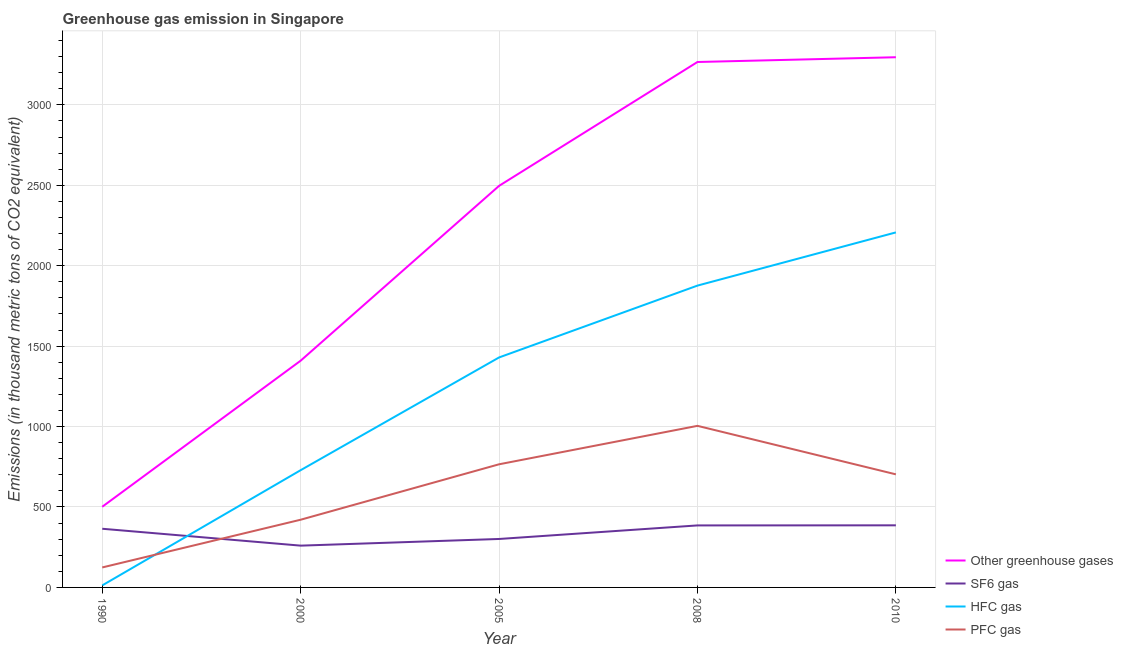How many different coloured lines are there?
Provide a short and direct response. 4. Does the line corresponding to emission of hfc gas intersect with the line corresponding to emission of pfc gas?
Your answer should be very brief. Yes. What is the emission of hfc gas in 2005?
Your answer should be compact. 1429.7. Across all years, what is the maximum emission of greenhouse gases?
Provide a succinct answer. 3296. Across all years, what is the minimum emission of pfc gas?
Offer a terse response. 124.2. In which year was the emission of sf6 gas minimum?
Provide a succinct answer. 2000. What is the total emission of greenhouse gases in the graph?
Your answer should be very brief. 1.10e+04. What is the difference between the emission of hfc gas in 2000 and that in 2005?
Your response must be concise. -700.8. What is the difference between the emission of hfc gas in 2008 and the emission of greenhouse gases in 2010?
Make the answer very short. -1419.6. What is the average emission of pfc gas per year?
Your answer should be very brief. 603.62. In the year 1990, what is the difference between the emission of greenhouse gases and emission of sf6 gas?
Your response must be concise. 136.8. What is the ratio of the emission of sf6 gas in 1990 to that in 2000?
Provide a succinct answer. 1.4. Is the emission of greenhouse gases in 1990 less than that in 2000?
Your answer should be very brief. Yes. Is the difference between the emission of sf6 gas in 2000 and 2008 greater than the difference between the emission of hfc gas in 2000 and 2008?
Provide a succinct answer. Yes. What is the difference between the highest and the lowest emission of hfc gas?
Make the answer very short. 2194.4. In how many years, is the emission of pfc gas greater than the average emission of pfc gas taken over all years?
Offer a very short reply. 3. Is it the case that in every year, the sum of the emission of greenhouse gases and emission of hfc gas is greater than the sum of emission of sf6 gas and emission of pfc gas?
Ensure brevity in your answer.  No. Is it the case that in every year, the sum of the emission of greenhouse gases and emission of sf6 gas is greater than the emission of hfc gas?
Make the answer very short. Yes. Does the emission of hfc gas monotonically increase over the years?
Ensure brevity in your answer.  Yes. Does the graph contain any zero values?
Provide a succinct answer. No. Does the graph contain grids?
Keep it short and to the point. Yes. Where does the legend appear in the graph?
Your response must be concise. Bottom right. How many legend labels are there?
Keep it short and to the point. 4. How are the legend labels stacked?
Give a very brief answer. Vertical. What is the title of the graph?
Your answer should be compact. Greenhouse gas emission in Singapore. Does "Argument" appear as one of the legend labels in the graph?
Keep it short and to the point. No. What is the label or title of the X-axis?
Your response must be concise. Year. What is the label or title of the Y-axis?
Provide a succinct answer. Emissions (in thousand metric tons of CO2 equivalent). What is the Emissions (in thousand metric tons of CO2 equivalent) in Other greenhouse gases in 1990?
Provide a short and direct response. 501.5. What is the Emissions (in thousand metric tons of CO2 equivalent) of SF6 gas in 1990?
Your response must be concise. 364.7. What is the Emissions (in thousand metric tons of CO2 equivalent) in HFC gas in 1990?
Your response must be concise. 12.6. What is the Emissions (in thousand metric tons of CO2 equivalent) of PFC gas in 1990?
Offer a terse response. 124.2. What is the Emissions (in thousand metric tons of CO2 equivalent) of Other greenhouse gases in 2000?
Your answer should be very brief. 1409.6. What is the Emissions (in thousand metric tons of CO2 equivalent) in SF6 gas in 2000?
Give a very brief answer. 259.8. What is the Emissions (in thousand metric tons of CO2 equivalent) in HFC gas in 2000?
Provide a succinct answer. 728.9. What is the Emissions (in thousand metric tons of CO2 equivalent) in PFC gas in 2000?
Your answer should be very brief. 420.9. What is the Emissions (in thousand metric tons of CO2 equivalent) in Other greenhouse gases in 2005?
Provide a short and direct response. 2496.4. What is the Emissions (in thousand metric tons of CO2 equivalent) of SF6 gas in 2005?
Provide a succinct answer. 301.2. What is the Emissions (in thousand metric tons of CO2 equivalent) in HFC gas in 2005?
Keep it short and to the point. 1429.7. What is the Emissions (in thousand metric tons of CO2 equivalent) in PFC gas in 2005?
Your response must be concise. 765.5. What is the Emissions (in thousand metric tons of CO2 equivalent) of Other greenhouse gases in 2008?
Provide a succinct answer. 3266.4. What is the Emissions (in thousand metric tons of CO2 equivalent) of SF6 gas in 2008?
Your response must be concise. 385.5. What is the Emissions (in thousand metric tons of CO2 equivalent) of HFC gas in 2008?
Make the answer very short. 1876.4. What is the Emissions (in thousand metric tons of CO2 equivalent) of PFC gas in 2008?
Ensure brevity in your answer.  1004.5. What is the Emissions (in thousand metric tons of CO2 equivalent) in Other greenhouse gases in 2010?
Offer a terse response. 3296. What is the Emissions (in thousand metric tons of CO2 equivalent) of SF6 gas in 2010?
Keep it short and to the point. 386. What is the Emissions (in thousand metric tons of CO2 equivalent) of HFC gas in 2010?
Make the answer very short. 2207. What is the Emissions (in thousand metric tons of CO2 equivalent) in PFC gas in 2010?
Make the answer very short. 703. Across all years, what is the maximum Emissions (in thousand metric tons of CO2 equivalent) of Other greenhouse gases?
Your answer should be very brief. 3296. Across all years, what is the maximum Emissions (in thousand metric tons of CO2 equivalent) in SF6 gas?
Your response must be concise. 386. Across all years, what is the maximum Emissions (in thousand metric tons of CO2 equivalent) of HFC gas?
Offer a very short reply. 2207. Across all years, what is the maximum Emissions (in thousand metric tons of CO2 equivalent) in PFC gas?
Make the answer very short. 1004.5. Across all years, what is the minimum Emissions (in thousand metric tons of CO2 equivalent) in Other greenhouse gases?
Make the answer very short. 501.5. Across all years, what is the minimum Emissions (in thousand metric tons of CO2 equivalent) in SF6 gas?
Your response must be concise. 259.8. Across all years, what is the minimum Emissions (in thousand metric tons of CO2 equivalent) of HFC gas?
Offer a terse response. 12.6. Across all years, what is the minimum Emissions (in thousand metric tons of CO2 equivalent) of PFC gas?
Keep it short and to the point. 124.2. What is the total Emissions (in thousand metric tons of CO2 equivalent) of Other greenhouse gases in the graph?
Provide a short and direct response. 1.10e+04. What is the total Emissions (in thousand metric tons of CO2 equivalent) in SF6 gas in the graph?
Provide a succinct answer. 1697.2. What is the total Emissions (in thousand metric tons of CO2 equivalent) in HFC gas in the graph?
Your answer should be very brief. 6254.6. What is the total Emissions (in thousand metric tons of CO2 equivalent) in PFC gas in the graph?
Provide a short and direct response. 3018.1. What is the difference between the Emissions (in thousand metric tons of CO2 equivalent) of Other greenhouse gases in 1990 and that in 2000?
Make the answer very short. -908.1. What is the difference between the Emissions (in thousand metric tons of CO2 equivalent) in SF6 gas in 1990 and that in 2000?
Ensure brevity in your answer.  104.9. What is the difference between the Emissions (in thousand metric tons of CO2 equivalent) in HFC gas in 1990 and that in 2000?
Provide a succinct answer. -716.3. What is the difference between the Emissions (in thousand metric tons of CO2 equivalent) of PFC gas in 1990 and that in 2000?
Provide a short and direct response. -296.7. What is the difference between the Emissions (in thousand metric tons of CO2 equivalent) in Other greenhouse gases in 1990 and that in 2005?
Make the answer very short. -1994.9. What is the difference between the Emissions (in thousand metric tons of CO2 equivalent) of SF6 gas in 1990 and that in 2005?
Your answer should be very brief. 63.5. What is the difference between the Emissions (in thousand metric tons of CO2 equivalent) of HFC gas in 1990 and that in 2005?
Offer a terse response. -1417.1. What is the difference between the Emissions (in thousand metric tons of CO2 equivalent) of PFC gas in 1990 and that in 2005?
Your answer should be compact. -641.3. What is the difference between the Emissions (in thousand metric tons of CO2 equivalent) in Other greenhouse gases in 1990 and that in 2008?
Provide a short and direct response. -2764.9. What is the difference between the Emissions (in thousand metric tons of CO2 equivalent) in SF6 gas in 1990 and that in 2008?
Your answer should be compact. -20.8. What is the difference between the Emissions (in thousand metric tons of CO2 equivalent) in HFC gas in 1990 and that in 2008?
Ensure brevity in your answer.  -1863.8. What is the difference between the Emissions (in thousand metric tons of CO2 equivalent) of PFC gas in 1990 and that in 2008?
Provide a succinct answer. -880.3. What is the difference between the Emissions (in thousand metric tons of CO2 equivalent) in Other greenhouse gases in 1990 and that in 2010?
Offer a very short reply. -2794.5. What is the difference between the Emissions (in thousand metric tons of CO2 equivalent) in SF6 gas in 1990 and that in 2010?
Offer a very short reply. -21.3. What is the difference between the Emissions (in thousand metric tons of CO2 equivalent) in HFC gas in 1990 and that in 2010?
Provide a succinct answer. -2194.4. What is the difference between the Emissions (in thousand metric tons of CO2 equivalent) in PFC gas in 1990 and that in 2010?
Keep it short and to the point. -578.8. What is the difference between the Emissions (in thousand metric tons of CO2 equivalent) of Other greenhouse gases in 2000 and that in 2005?
Offer a terse response. -1086.8. What is the difference between the Emissions (in thousand metric tons of CO2 equivalent) of SF6 gas in 2000 and that in 2005?
Ensure brevity in your answer.  -41.4. What is the difference between the Emissions (in thousand metric tons of CO2 equivalent) of HFC gas in 2000 and that in 2005?
Give a very brief answer. -700.8. What is the difference between the Emissions (in thousand metric tons of CO2 equivalent) in PFC gas in 2000 and that in 2005?
Make the answer very short. -344.6. What is the difference between the Emissions (in thousand metric tons of CO2 equivalent) in Other greenhouse gases in 2000 and that in 2008?
Your answer should be compact. -1856.8. What is the difference between the Emissions (in thousand metric tons of CO2 equivalent) of SF6 gas in 2000 and that in 2008?
Give a very brief answer. -125.7. What is the difference between the Emissions (in thousand metric tons of CO2 equivalent) of HFC gas in 2000 and that in 2008?
Keep it short and to the point. -1147.5. What is the difference between the Emissions (in thousand metric tons of CO2 equivalent) of PFC gas in 2000 and that in 2008?
Provide a succinct answer. -583.6. What is the difference between the Emissions (in thousand metric tons of CO2 equivalent) in Other greenhouse gases in 2000 and that in 2010?
Provide a succinct answer. -1886.4. What is the difference between the Emissions (in thousand metric tons of CO2 equivalent) in SF6 gas in 2000 and that in 2010?
Your answer should be compact. -126.2. What is the difference between the Emissions (in thousand metric tons of CO2 equivalent) in HFC gas in 2000 and that in 2010?
Make the answer very short. -1478.1. What is the difference between the Emissions (in thousand metric tons of CO2 equivalent) in PFC gas in 2000 and that in 2010?
Your answer should be compact. -282.1. What is the difference between the Emissions (in thousand metric tons of CO2 equivalent) in Other greenhouse gases in 2005 and that in 2008?
Your answer should be very brief. -770. What is the difference between the Emissions (in thousand metric tons of CO2 equivalent) in SF6 gas in 2005 and that in 2008?
Your answer should be compact. -84.3. What is the difference between the Emissions (in thousand metric tons of CO2 equivalent) in HFC gas in 2005 and that in 2008?
Your answer should be very brief. -446.7. What is the difference between the Emissions (in thousand metric tons of CO2 equivalent) in PFC gas in 2005 and that in 2008?
Give a very brief answer. -239. What is the difference between the Emissions (in thousand metric tons of CO2 equivalent) of Other greenhouse gases in 2005 and that in 2010?
Give a very brief answer. -799.6. What is the difference between the Emissions (in thousand metric tons of CO2 equivalent) of SF6 gas in 2005 and that in 2010?
Make the answer very short. -84.8. What is the difference between the Emissions (in thousand metric tons of CO2 equivalent) in HFC gas in 2005 and that in 2010?
Offer a very short reply. -777.3. What is the difference between the Emissions (in thousand metric tons of CO2 equivalent) of PFC gas in 2005 and that in 2010?
Ensure brevity in your answer.  62.5. What is the difference between the Emissions (in thousand metric tons of CO2 equivalent) of Other greenhouse gases in 2008 and that in 2010?
Ensure brevity in your answer.  -29.6. What is the difference between the Emissions (in thousand metric tons of CO2 equivalent) in HFC gas in 2008 and that in 2010?
Ensure brevity in your answer.  -330.6. What is the difference between the Emissions (in thousand metric tons of CO2 equivalent) in PFC gas in 2008 and that in 2010?
Your answer should be compact. 301.5. What is the difference between the Emissions (in thousand metric tons of CO2 equivalent) of Other greenhouse gases in 1990 and the Emissions (in thousand metric tons of CO2 equivalent) of SF6 gas in 2000?
Your answer should be compact. 241.7. What is the difference between the Emissions (in thousand metric tons of CO2 equivalent) of Other greenhouse gases in 1990 and the Emissions (in thousand metric tons of CO2 equivalent) of HFC gas in 2000?
Offer a terse response. -227.4. What is the difference between the Emissions (in thousand metric tons of CO2 equivalent) of Other greenhouse gases in 1990 and the Emissions (in thousand metric tons of CO2 equivalent) of PFC gas in 2000?
Provide a succinct answer. 80.6. What is the difference between the Emissions (in thousand metric tons of CO2 equivalent) in SF6 gas in 1990 and the Emissions (in thousand metric tons of CO2 equivalent) in HFC gas in 2000?
Give a very brief answer. -364.2. What is the difference between the Emissions (in thousand metric tons of CO2 equivalent) in SF6 gas in 1990 and the Emissions (in thousand metric tons of CO2 equivalent) in PFC gas in 2000?
Provide a succinct answer. -56.2. What is the difference between the Emissions (in thousand metric tons of CO2 equivalent) of HFC gas in 1990 and the Emissions (in thousand metric tons of CO2 equivalent) of PFC gas in 2000?
Offer a terse response. -408.3. What is the difference between the Emissions (in thousand metric tons of CO2 equivalent) of Other greenhouse gases in 1990 and the Emissions (in thousand metric tons of CO2 equivalent) of SF6 gas in 2005?
Your answer should be compact. 200.3. What is the difference between the Emissions (in thousand metric tons of CO2 equivalent) in Other greenhouse gases in 1990 and the Emissions (in thousand metric tons of CO2 equivalent) in HFC gas in 2005?
Your answer should be compact. -928.2. What is the difference between the Emissions (in thousand metric tons of CO2 equivalent) in Other greenhouse gases in 1990 and the Emissions (in thousand metric tons of CO2 equivalent) in PFC gas in 2005?
Your answer should be compact. -264. What is the difference between the Emissions (in thousand metric tons of CO2 equivalent) in SF6 gas in 1990 and the Emissions (in thousand metric tons of CO2 equivalent) in HFC gas in 2005?
Your answer should be compact. -1065. What is the difference between the Emissions (in thousand metric tons of CO2 equivalent) of SF6 gas in 1990 and the Emissions (in thousand metric tons of CO2 equivalent) of PFC gas in 2005?
Your answer should be compact. -400.8. What is the difference between the Emissions (in thousand metric tons of CO2 equivalent) of HFC gas in 1990 and the Emissions (in thousand metric tons of CO2 equivalent) of PFC gas in 2005?
Provide a succinct answer. -752.9. What is the difference between the Emissions (in thousand metric tons of CO2 equivalent) in Other greenhouse gases in 1990 and the Emissions (in thousand metric tons of CO2 equivalent) in SF6 gas in 2008?
Make the answer very short. 116. What is the difference between the Emissions (in thousand metric tons of CO2 equivalent) of Other greenhouse gases in 1990 and the Emissions (in thousand metric tons of CO2 equivalent) of HFC gas in 2008?
Offer a terse response. -1374.9. What is the difference between the Emissions (in thousand metric tons of CO2 equivalent) of Other greenhouse gases in 1990 and the Emissions (in thousand metric tons of CO2 equivalent) of PFC gas in 2008?
Offer a very short reply. -503. What is the difference between the Emissions (in thousand metric tons of CO2 equivalent) of SF6 gas in 1990 and the Emissions (in thousand metric tons of CO2 equivalent) of HFC gas in 2008?
Offer a terse response. -1511.7. What is the difference between the Emissions (in thousand metric tons of CO2 equivalent) of SF6 gas in 1990 and the Emissions (in thousand metric tons of CO2 equivalent) of PFC gas in 2008?
Give a very brief answer. -639.8. What is the difference between the Emissions (in thousand metric tons of CO2 equivalent) in HFC gas in 1990 and the Emissions (in thousand metric tons of CO2 equivalent) in PFC gas in 2008?
Provide a succinct answer. -991.9. What is the difference between the Emissions (in thousand metric tons of CO2 equivalent) of Other greenhouse gases in 1990 and the Emissions (in thousand metric tons of CO2 equivalent) of SF6 gas in 2010?
Your answer should be compact. 115.5. What is the difference between the Emissions (in thousand metric tons of CO2 equivalent) of Other greenhouse gases in 1990 and the Emissions (in thousand metric tons of CO2 equivalent) of HFC gas in 2010?
Offer a terse response. -1705.5. What is the difference between the Emissions (in thousand metric tons of CO2 equivalent) in Other greenhouse gases in 1990 and the Emissions (in thousand metric tons of CO2 equivalent) in PFC gas in 2010?
Offer a terse response. -201.5. What is the difference between the Emissions (in thousand metric tons of CO2 equivalent) of SF6 gas in 1990 and the Emissions (in thousand metric tons of CO2 equivalent) of HFC gas in 2010?
Make the answer very short. -1842.3. What is the difference between the Emissions (in thousand metric tons of CO2 equivalent) in SF6 gas in 1990 and the Emissions (in thousand metric tons of CO2 equivalent) in PFC gas in 2010?
Offer a very short reply. -338.3. What is the difference between the Emissions (in thousand metric tons of CO2 equivalent) in HFC gas in 1990 and the Emissions (in thousand metric tons of CO2 equivalent) in PFC gas in 2010?
Provide a short and direct response. -690.4. What is the difference between the Emissions (in thousand metric tons of CO2 equivalent) of Other greenhouse gases in 2000 and the Emissions (in thousand metric tons of CO2 equivalent) of SF6 gas in 2005?
Offer a terse response. 1108.4. What is the difference between the Emissions (in thousand metric tons of CO2 equivalent) in Other greenhouse gases in 2000 and the Emissions (in thousand metric tons of CO2 equivalent) in HFC gas in 2005?
Offer a very short reply. -20.1. What is the difference between the Emissions (in thousand metric tons of CO2 equivalent) of Other greenhouse gases in 2000 and the Emissions (in thousand metric tons of CO2 equivalent) of PFC gas in 2005?
Give a very brief answer. 644.1. What is the difference between the Emissions (in thousand metric tons of CO2 equivalent) in SF6 gas in 2000 and the Emissions (in thousand metric tons of CO2 equivalent) in HFC gas in 2005?
Give a very brief answer. -1169.9. What is the difference between the Emissions (in thousand metric tons of CO2 equivalent) in SF6 gas in 2000 and the Emissions (in thousand metric tons of CO2 equivalent) in PFC gas in 2005?
Ensure brevity in your answer.  -505.7. What is the difference between the Emissions (in thousand metric tons of CO2 equivalent) in HFC gas in 2000 and the Emissions (in thousand metric tons of CO2 equivalent) in PFC gas in 2005?
Your response must be concise. -36.6. What is the difference between the Emissions (in thousand metric tons of CO2 equivalent) of Other greenhouse gases in 2000 and the Emissions (in thousand metric tons of CO2 equivalent) of SF6 gas in 2008?
Provide a succinct answer. 1024.1. What is the difference between the Emissions (in thousand metric tons of CO2 equivalent) of Other greenhouse gases in 2000 and the Emissions (in thousand metric tons of CO2 equivalent) of HFC gas in 2008?
Your response must be concise. -466.8. What is the difference between the Emissions (in thousand metric tons of CO2 equivalent) in Other greenhouse gases in 2000 and the Emissions (in thousand metric tons of CO2 equivalent) in PFC gas in 2008?
Keep it short and to the point. 405.1. What is the difference between the Emissions (in thousand metric tons of CO2 equivalent) of SF6 gas in 2000 and the Emissions (in thousand metric tons of CO2 equivalent) of HFC gas in 2008?
Offer a very short reply. -1616.6. What is the difference between the Emissions (in thousand metric tons of CO2 equivalent) of SF6 gas in 2000 and the Emissions (in thousand metric tons of CO2 equivalent) of PFC gas in 2008?
Your answer should be compact. -744.7. What is the difference between the Emissions (in thousand metric tons of CO2 equivalent) of HFC gas in 2000 and the Emissions (in thousand metric tons of CO2 equivalent) of PFC gas in 2008?
Your answer should be compact. -275.6. What is the difference between the Emissions (in thousand metric tons of CO2 equivalent) in Other greenhouse gases in 2000 and the Emissions (in thousand metric tons of CO2 equivalent) in SF6 gas in 2010?
Offer a very short reply. 1023.6. What is the difference between the Emissions (in thousand metric tons of CO2 equivalent) in Other greenhouse gases in 2000 and the Emissions (in thousand metric tons of CO2 equivalent) in HFC gas in 2010?
Offer a terse response. -797.4. What is the difference between the Emissions (in thousand metric tons of CO2 equivalent) of Other greenhouse gases in 2000 and the Emissions (in thousand metric tons of CO2 equivalent) of PFC gas in 2010?
Make the answer very short. 706.6. What is the difference between the Emissions (in thousand metric tons of CO2 equivalent) in SF6 gas in 2000 and the Emissions (in thousand metric tons of CO2 equivalent) in HFC gas in 2010?
Ensure brevity in your answer.  -1947.2. What is the difference between the Emissions (in thousand metric tons of CO2 equivalent) in SF6 gas in 2000 and the Emissions (in thousand metric tons of CO2 equivalent) in PFC gas in 2010?
Give a very brief answer. -443.2. What is the difference between the Emissions (in thousand metric tons of CO2 equivalent) of HFC gas in 2000 and the Emissions (in thousand metric tons of CO2 equivalent) of PFC gas in 2010?
Your answer should be compact. 25.9. What is the difference between the Emissions (in thousand metric tons of CO2 equivalent) in Other greenhouse gases in 2005 and the Emissions (in thousand metric tons of CO2 equivalent) in SF6 gas in 2008?
Your answer should be very brief. 2110.9. What is the difference between the Emissions (in thousand metric tons of CO2 equivalent) of Other greenhouse gases in 2005 and the Emissions (in thousand metric tons of CO2 equivalent) of HFC gas in 2008?
Provide a succinct answer. 620. What is the difference between the Emissions (in thousand metric tons of CO2 equivalent) in Other greenhouse gases in 2005 and the Emissions (in thousand metric tons of CO2 equivalent) in PFC gas in 2008?
Provide a succinct answer. 1491.9. What is the difference between the Emissions (in thousand metric tons of CO2 equivalent) of SF6 gas in 2005 and the Emissions (in thousand metric tons of CO2 equivalent) of HFC gas in 2008?
Make the answer very short. -1575.2. What is the difference between the Emissions (in thousand metric tons of CO2 equivalent) in SF6 gas in 2005 and the Emissions (in thousand metric tons of CO2 equivalent) in PFC gas in 2008?
Offer a terse response. -703.3. What is the difference between the Emissions (in thousand metric tons of CO2 equivalent) of HFC gas in 2005 and the Emissions (in thousand metric tons of CO2 equivalent) of PFC gas in 2008?
Ensure brevity in your answer.  425.2. What is the difference between the Emissions (in thousand metric tons of CO2 equivalent) of Other greenhouse gases in 2005 and the Emissions (in thousand metric tons of CO2 equivalent) of SF6 gas in 2010?
Offer a terse response. 2110.4. What is the difference between the Emissions (in thousand metric tons of CO2 equivalent) of Other greenhouse gases in 2005 and the Emissions (in thousand metric tons of CO2 equivalent) of HFC gas in 2010?
Ensure brevity in your answer.  289.4. What is the difference between the Emissions (in thousand metric tons of CO2 equivalent) in Other greenhouse gases in 2005 and the Emissions (in thousand metric tons of CO2 equivalent) in PFC gas in 2010?
Offer a very short reply. 1793.4. What is the difference between the Emissions (in thousand metric tons of CO2 equivalent) in SF6 gas in 2005 and the Emissions (in thousand metric tons of CO2 equivalent) in HFC gas in 2010?
Give a very brief answer. -1905.8. What is the difference between the Emissions (in thousand metric tons of CO2 equivalent) in SF6 gas in 2005 and the Emissions (in thousand metric tons of CO2 equivalent) in PFC gas in 2010?
Your answer should be compact. -401.8. What is the difference between the Emissions (in thousand metric tons of CO2 equivalent) of HFC gas in 2005 and the Emissions (in thousand metric tons of CO2 equivalent) of PFC gas in 2010?
Offer a terse response. 726.7. What is the difference between the Emissions (in thousand metric tons of CO2 equivalent) in Other greenhouse gases in 2008 and the Emissions (in thousand metric tons of CO2 equivalent) in SF6 gas in 2010?
Make the answer very short. 2880.4. What is the difference between the Emissions (in thousand metric tons of CO2 equivalent) of Other greenhouse gases in 2008 and the Emissions (in thousand metric tons of CO2 equivalent) of HFC gas in 2010?
Offer a terse response. 1059.4. What is the difference between the Emissions (in thousand metric tons of CO2 equivalent) in Other greenhouse gases in 2008 and the Emissions (in thousand metric tons of CO2 equivalent) in PFC gas in 2010?
Give a very brief answer. 2563.4. What is the difference between the Emissions (in thousand metric tons of CO2 equivalent) in SF6 gas in 2008 and the Emissions (in thousand metric tons of CO2 equivalent) in HFC gas in 2010?
Give a very brief answer. -1821.5. What is the difference between the Emissions (in thousand metric tons of CO2 equivalent) of SF6 gas in 2008 and the Emissions (in thousand metric tons of CO2 equivalent) of PFC gas in 2010?
Provide a succinct answer. -317.5. What is the difference between the Emissions (in thousand metric tons of CO2 equivalent) in HFC gas in 2008 and the Emissions (in thousand metric tons of CO2 equivalent) in PFC gas in 2010?
Your answer should be compact. 1173.4. What is the average Emissions (in thousand metric tons of CO2 equivalent) of Other greenhouse gases per year?
Offer a terse response. 2193.98. What is the average Emissions (in thousand metric tons of CO2 equivalent) of SF6 gas per year?
Your answer should be very brief. 339.44. What is the average Emissions (in thousand metric tons of CO2 equivalent) in HFC gas per year?
Ensure brevity in your answer.  1250.92. What is the average Emissions (in thousand metric tons of CO2 equivalent) of PFC gas per year?
Make the answer very short. 603.62. In the year 1990, what is the difference between the Emissions (in thousand metric tons of CO2 equivalent) in Other greenhouse gases and Emissions (in thousand metric tons of CO2 equivalent) in SF6 gas?
Provide a short and direct response. 136.8. In the year 1990, what is the difference between the Emissions (in thousand metric tons of CO2 equivalent) in Other greenhouse gases and Emissions (in thousand metric tons of CO2 equivalent) in HFC gas?
Make the answer very short. 488.9. In the year 1990, what is the difference between the Emissions (in thousand metric tons of CO2 equivalent) of Other greenhouse gases and Emissions (in thousand metric tons of CO2 equivalent) of PFC gas?
Give a very brief answer. 377.3. In the year 1990, what is the difference between the Emissions (in thousand metric tons of CO2 equivalent) in SF6 gas and Emissions (in thousand metric tons of CO2 equivalent) in HFC gas?
Provide a short and direct response. 352.1. In the year 1990, what is the difference between the Emissions (in thousand metric tons of CO2 equivalent) in SF6 gas and Emissions (in thousand metric tons of CO2 equivalent) in PFC gas?
Ensure brevity in your answer.  240.5. In the year 1990, what is the difference between the Emissions (in thousand metric tons of CO2 equivalent) in HFC gas and Emissions (in thousand metric tons of CO2 equivalent) in PFC gas?
Make the answer very short. -111.6. In the year 2000, what is the difference between the Emissions (in thousand metric tons of CO2 equivalent) in Other greenhouse gases and Emissions (in thousand metric tons of CO2 equivalent) in SF6 gas?
Keep it short and to the point. 1149.8. In the year 2000, what is the difference between the Emissions (in thousand metric tons of CO2 equivalent) in Other greenhouse gases and Emissions (in thousand metric tons of CO2 equivalent) in HFC gas?
Offer a very short reply. 680.7. In the year 2000, what is the difference between the Emissions (in thousand metric tons of CO2 equivalent) in Other greenhouse gases and Emissions (in thousand metric tons of CO2 equivalent) in PFC gas?
Your response must be concise. 988.7. In the year 2000, what is the difference between the Emissions (in thousand metric tons of CO2 equivalent) of SF6 gas and Emissions (in thousand metric tons of CO2 equivalent) of HFC gas?
Offer a very short reply. -469.1. In the year 2000, what is the difference between the Emissions (in thousand metric tons of CO2 equivalent) of SF6 gas and Emissions (in thousand metric tons of CO2 equivalent) of PFC gas?
Your answer should be very brief. -161.1. In the year 2000, what is the difference between the Emissions (in thousand metric tons of CO2 equivalent) in HFC gas and Emissions (in thousand metric tons of CO2 equivalent) in PFC gas?
Provide a succinct answer. 308. In the year 2005, what is the difference between the Emissions (in thousand metric tons of CO2 equivalent) in Other greenhouse gases and Emissions (in thousand metric tons of CO2 equivalent) in SF6 gas?
Make the answer very short. 2195.2. In the year 2005, what is the difference between the Emissions (in thousand metric tons of CO2 equivalent) of Other greenhouse gases and Emissions (in thousand metric tons of CO2 equivalent) of HFC gas?
Provide a succinct answer. 1066.7. In the year 2005, what is the difference between the Emissions (in thousand metric tons of CO2 equivalent) in Other greenhouse gases and Emissions (in thousand metric tons of CO2 equivalent) in PFC gas?
Your answer should be very brief. 1730.9. In the year 2005, what is the difference between the Emissions (in thousand metric tons of CO2 equivalent) of SF6 gas and Emissions (in thousand metric tons of CO2 equivalent) of HFC gas?
Offer a very short reply. -1128.5. In the year 2005, what is the difference between the Emissions (in thousand metric tons of CO2 equivalent) of SF6 gas and Emissions (in thousand metric tons of CO2 equivalent) of PFC gas?
Provide a succinct answer. -464.3. In the year 2005, what is the difference between the Emissions (in thousand metric tons of CO2 equivalent) in HFC gas and Emissions (in thousand metric tons of CO2 equivalent) in PFC gas?
Your response must be concise. 664.2. In the year 2008, what is the difference between the Emissions (in thousand metric tons of CO2 equivalent) of Other greenhouse gases and Emissions (in thousand metric tons of CO2 equivalent) of SF6 gas?
Give a very brief answer. 2880.9. In the year 2008, what is the difference between the Emissions (in thousand metric tons of CO2 equivalent) in Other greenhouse gases and Emissions (in thousand metric tons of CO2 equivalent) in HFC gas?
Provide a succinct answer. 1390. In the year 2008, what is the difference between the Emissions (in thousand metric tons of CO2 equivalent) of Other greenhouse gases and Emissions (in thousand metric tons of CO2 equivalent) of PFC gas?
Give a very brief answer. 2261.9. In the year 2008, what is the difference between the Emissions (in thousand metric tons of CO2 equivalent) in SF6 gas and Emissions (in thousand metric tons of CO2 equivalent) in HFC gas?
Your answer should be compact. -1490.9. In the year 2008, what is the difference between the Emissions (in thousand metric tons of CO2 equivalent) in SF6 gas and Emissions (in thousand metric tons of CO2 equivalent) in PFC gas?
Ensure brevity in your answer.  -619. In the year 2008, what is the difference between the Emissions (in thousand metric tons of CO2 equivalent) in HFC gas and Emissions (in thousand metric tons of CO2 equivalent) in PFC gas?
Offer a very short reply. 871.9. In the year 2010, what is the difference between the Emissions (in thousand metric tons of CO2 equivalent) in Other greenhouse gases and Emissions (in thousand metric tons of CO2 equivalent) in SF6 gas?
Your response must be concise. 2910. In the year 2010, what is the difference between the Emissions (in thousand metric tons of CO2 equivalent) in Other greenhouse gases and Emissions (in thousand metric tons of CO2 equivalent) in HFC gas?
Your response must be concise. 1089. In the year 2010, what is the difference between the Emissions (in thousand metric tons of CO2 equivalent) in Other greenhouse gases and Emissions (in thousand metric tons of CO2 equivalent) in PFC gas?
Offer a very short reply. 2593. In the year 2010, what is the difference between the Emissions (in thousand metric tons of CO2 equivalent) of SF6 gas and Emissions (in thousand metric tons of CO2 equivalent) of HFC gas?
Provide a short and direct response. -1821. In the year 2010, what is the difference between the Emissions (in thousand metric tons of CO2 equivalent) of SF6 gas and Emissions (in thousand metric tons of CO2 equivalent) of PFC gas?
Make the answer very short. -317. In the year 2010, what is the difference between the Emissions (in thousand metric tons of CO2 equivalent) of HFC gas and Emissions (in thousand metric tons of CO2 equivalent) of PFC gas?
Your answer should be very brief. 1504. What is the ratio of the Emissions (in thousand metric tons of CO2 equivalent) in Other greenhouse gases in 1990 to that in 2000?
Provide a succinct answer. 0.36. What is the ratio of the Emissions (in thousand metric tons of CO2 equivalent) in SF6 gas in 1990 to that in 2000?
Your answer should be compact. 1.4. What is the ratio of the Emissions (in thousand metric tons of CO2 equivalent) in HFC gas in 1990 to that in 2000?
Offer a very short reply. 0.02. What is the ratio of the Emissions (in thousand metric tons of CO2 equivalent) of PFC gas in 1990 to that in 2000?
Keep it short and to the point. 0.3. What is the ratio of the Emissions (in thousand metric tons of CO2 equivalent) in Other greenhouse gases in 1990 to that in 2005?
Give a very brief answer. 0.2. What is the ratio of the Emissions (in thousand metric tons of CO2 equivalent) in SF6 gas in 1990 to that in 2005?
Give a very brief answer. 1.21. What is the ratio of the Emissions (in thousand metric tons of CO2 equivalent) of HFC gas in 1990 to that in 2005?
Ensure brevity in your answer.  0.01. What is the ratio of the Emissions (in thousand metric tons of CO2 equivalent) in PFC gas in 1990 to that in 2005?
Provide a succinct answer. 0.16. What is the ratio of the Emissions (in thousand metric tons of CO2 equivalent) in Other greenhouse gases in 1990 to that in 2008?
Provide a succinct answer. 0.15. What is the ratio of the Emissions (in thousand metric tons of CO2 equivalent) in SF6 gas in 1990 to that in 2008?
Make the answer very short. 0.95. What is the ratio of the Emissions (in thousand metric tons of CO2 equivalent) of HFC gas in 1990 to that in 2008?
Provide a succinct answer. 0.01. What is the ratio of the Emissions (in thousand metric tons of CO2 equivalent) of PFC gas in 1990 to that in 2008?
Offer a terse response. 0.12. What is the ratio of the Emissions (in thousand metric tons of CO2 equivalent) of Other greenhouse gases in 1990 to that in 2010?
Your response must be concise. 0.15. What is the ratio of the Emissions (in thousand metric tons of CO2 equivalent) of SF6 gas in 1990 to that in 2010?
Provide a short and direct response. 0.94. What is the ratio of the Emissions (in thousand metric tons of CO2 equivalent) in HFC gas in 1990 to that in 2010?
Provide a succinct answer. 0.01. What is the ratio of the Emissions (in thousand metric tons of CO2 equivalent) of PFC gas in 1990 to that in 2010?
Make the answer very short. 0.18. What is the ratio of the Emissions (in thousand metric tons of CO2 equivalent) in Other greenhouse gases in 2000 to that in 2005?
Give a very brief answer. 0.56. What is the ratio of the Emissions (in thousand metric tons of CO2 equivalent) in SF6 gas in 2000 to that in 2005?
Your answer should be very brief. 0.86. What is the ratio of the Emissions (in thousand metric tons of CO2 equivalent) of HFC gas in 2000 to that in 2005?
Your answer should be compact. 0.51. What is the ratio of the Emissions (in thousand metric tons of CO2 equivalent) of PFC gas in 2000 to that in 2005?
Provide a short and direct response. 0.55. What is the ratio of the Emissions (in thousand metric tons of CO2 equivalent) of Other greenhouse gases in 2000 to that in 2008?
Your answer should be compact. 0.43. What is the ratio of the Emissions (in thousand metric tons of CO2 equivalent) of SF6 gas in 2000 to that in 2008?
Ensure brevity in your answer.  0.67. What is the ratio of the Emissions (in thousand metric tons of CO2 equivalent) of HFC gas in 2000 to that in 2008?
Offer a very short reply. 0.39. What is the ratio of the Emissions (in thousand metric tons of CO2 equivalent) of PFC gas in 2000 to that in 2008?
Your answer should be very brief. 0.42. What is the ratio of the Emissions (in thousand metric tons of CO2 equivalent) in Other greenhouse gases in 2000 to that in 2010?
Ensure brevity in your answer.  0.43. What is the ratio of the Emissions (in thousand metric tons of CO2 equivalent) of SF6 gas in 2000 to that in 2010?
Ensure brevity in your answer.  0.67. What is the ratio of the Emissions (in thousand metric tons of CO2 equivalent) in HFC gas in 2000 to that in 2010?
Ensure brevity in your answer.  0.33. What is the ratio of the Emissions (in thousand metric tons of CO2 equivalent) in PFC gas in 2000 to that in 2010?
Your response must be concise. 0.6. What is the ratio of the Emissions (in thousand metric tons of CO2 equivalent) in Other greenhouse gases in 2005 to that in 2008?
Your answer should be compact. 0.76. What is the ratio of the Emissions (in thousand metric tons of CO2 equivalent) in SF6 gas in 2005 to that in 2008?
Keep it short and to the point. 0.78. What is the ratio of the Emissions (in thousand metric tons of CO2 equivalent) in HFC gas in 2005 to that in 2008?
Your answer should be very brief. 0.76. What is the ratio of the Emissions (in thousand metric tons of CO2 equivalent) of PFC gas in 2005 to that in 2008?
Provide a short and direct response. 0.76. What is the ratio of the Emissions (in thousand metric tons of CO2 equivalent) in Other greenhouse gases in 2005 to that in 2010?
Your response must be concise. 0.76. What is the ratio of the Emissions (in thousand metric tons of CO2 equivalent) in SF6 gas in 2005 to that in 2010?
Make the answer very short. 0.78. What is the ratio of the Emissions (in thousand metric tons of CO2 equivalent) in HFC gas in 2005 to that in 2010?
Your answer should be compact. 0.65. What is the ratio of the Emissions (in thousand metric tons of CO2 equivalent) in PFC gas in 2005 to that in 2010?
Offer a very short reply. 1.09. What is the ratio of the Emissions (in thousand metric tons of CO2 equivalent) in Other greenhouse gases in 2008 to that in 2010?
Offer a terse response. 0.99. What is the ratio of the Emissions (in thousand metric tons of CO2 equivalent) of HFC gas in 2008 to that in 2010?
Your answer should be very brief. 0.85. What is the ratio of the Emissions (in thousand metric tons of CO2 equivalent) in PFC gas in 2008 to that in 2010?
Give a very brief answer. 1.43. What is the difference between the highest and the second highest Emissions (in thousand metric tons of CO2 equivalent) in Other greenhouse gases?
Keep it short and to the point. 29.6. What is the difference between the highest and the second highest Emissions (in thousand metric tons of CO2 equivalent) of SF6 gas?
Your response must be concise. 0.5. What is the difference between the highest and the second highest Emissions (in thousand metric tons of CO2 equivalent) in HFC gas?
Your answer should be compact. 330.6. What is the difference between the highest and the second highest Emissions (in thousand metric tons of CO2 equivalent) in PFC gas?
Give a very brief answer. 239. What is the difference between the highest and the lowest Emissions (in thousand metric tons of CO2 equivalent) in Other greenhouse gases?
Offer a very short reply. 2794.5. What is the difference between the highest and the lowest Emissions (in thousand metric tons of CO2 equivalent) of SF6 gas?
Your answer should be compact. 126.2. What is the difference between the highest and the lowest Emissions (in thousand metric tons of CO2 equivalent) of HFC gas?
Your answer should be compact. 2194.4. What is the difference between the highest and the lowest Emissions (in thousand metric tons of CO2 equivalent) in PFC gas?
Make the answer very short. 880.3. 